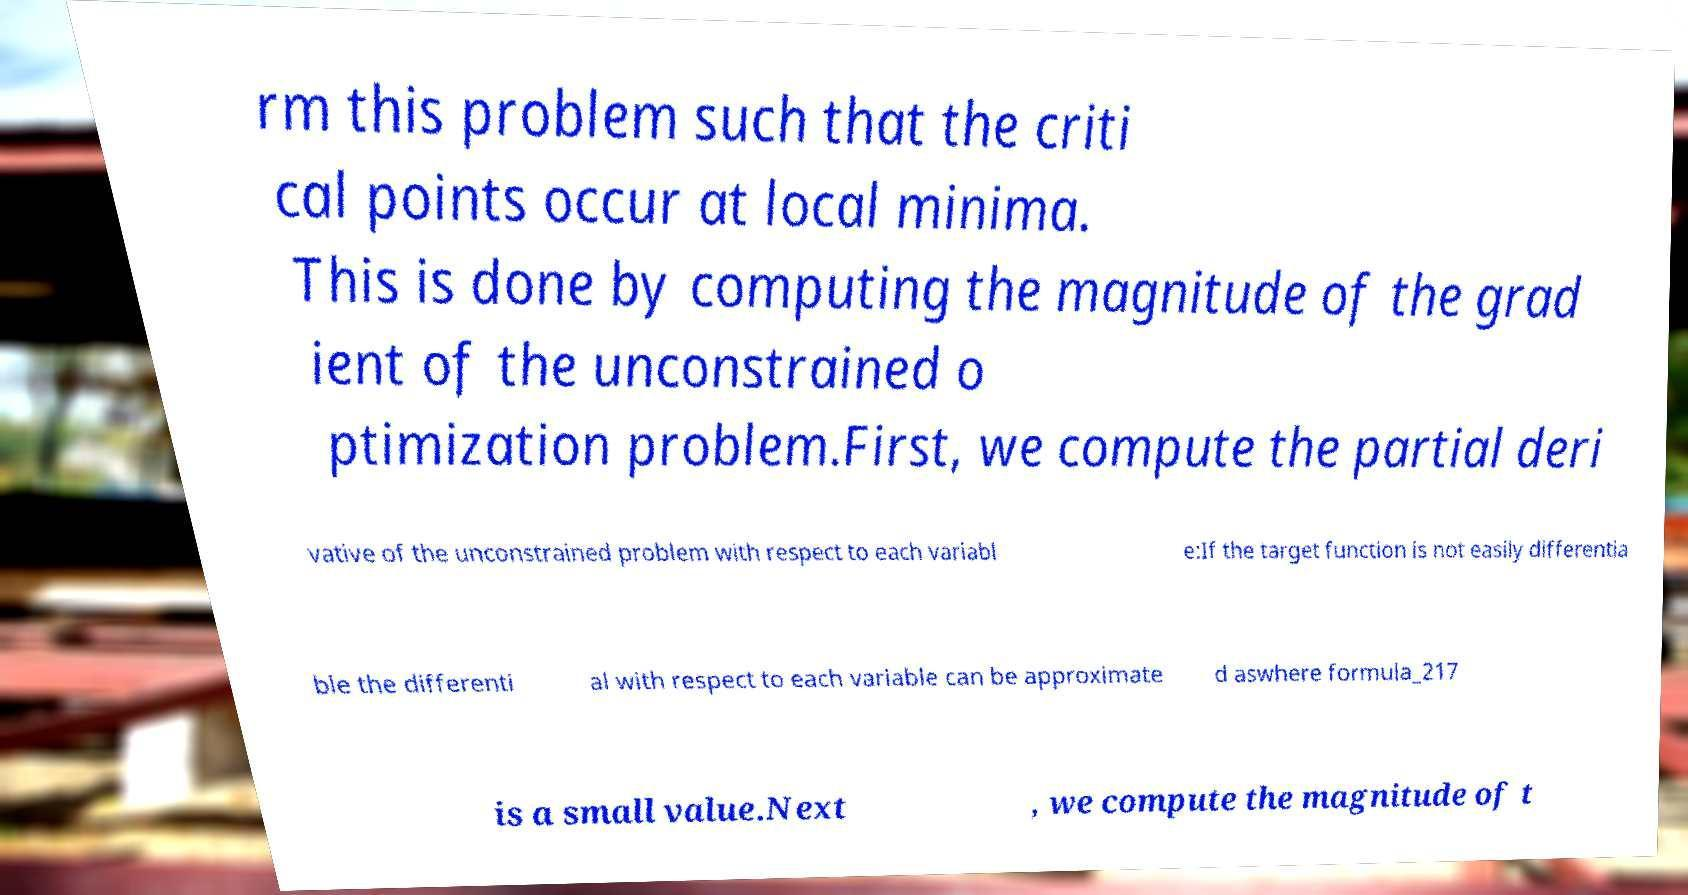Please read and relay the text visible in this image. What does it say? rm this problem such that the criti cal points occur at local minima. This is done by computing the magnitude of the grad ient of the unconstrained o ptimization problem.First, we compute the partial deri vative of the unconstrained problem with respect to each variabl e:If the target function is not easily differentia ble the differenti al with respect to each variable can be approximate d aswhere formula_217 is a small value.Next , we compute the magnitude of t 